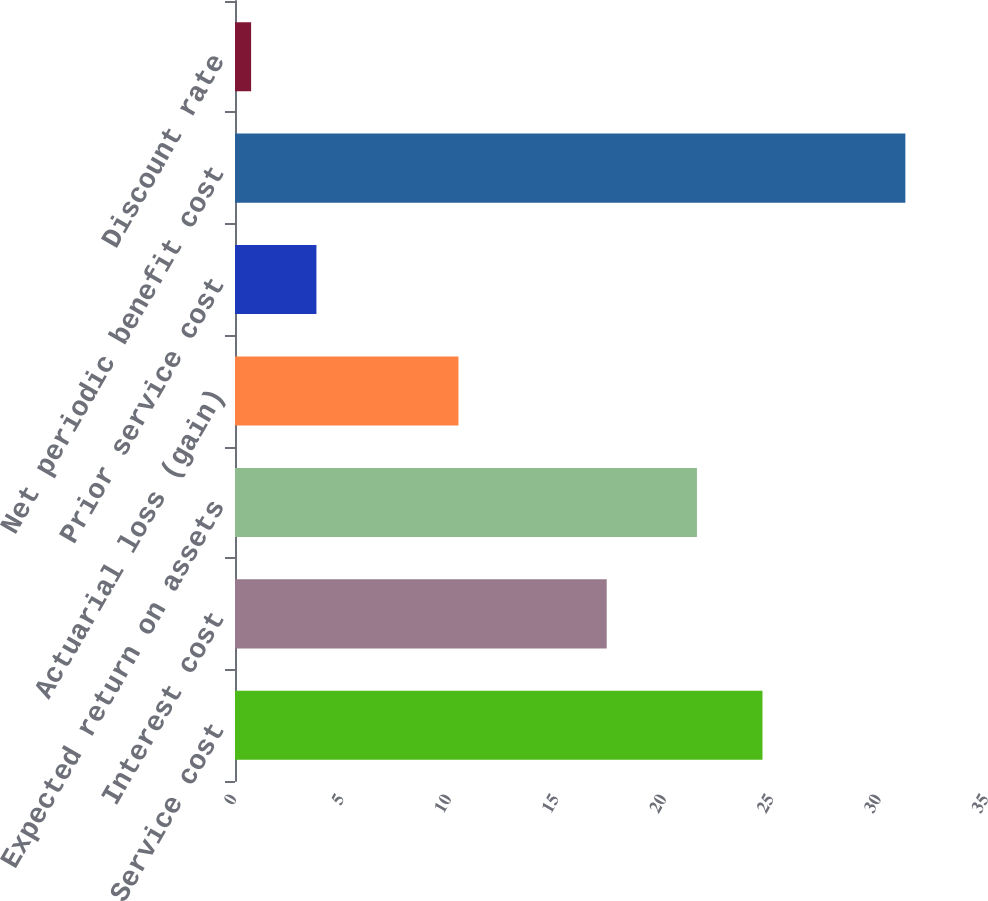Convert chart. <chart><loc_0><loc_0><loc_500><loc_500><bar_chart><fcel>Service cost<fcel>Interest cost<fcel>Expected return on assets<fcel>Actuarial loss (gain)<fcel>Prior service cost<fcel>Net periodic benefit cost<fcel>Discount rate<nl><fcel>24.55<fcel>17.3<fcel>21.5<fcel>10.4<fcel>3.79<fcel>31.2<fcel>0.75<nl></chart> 